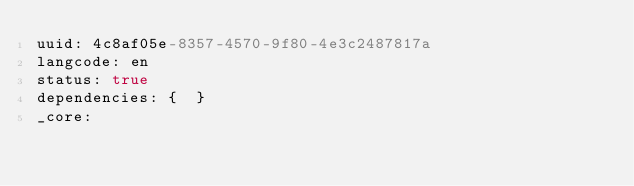Convert code to text. <code><loc_0><loc_0><loc_500><loc_500><_YAML_>uuid: 4c8af05e-8357-4570-9f80-4e3c2487817a
langcode: en
status: true
dependencies: {  }
_core:</code> 